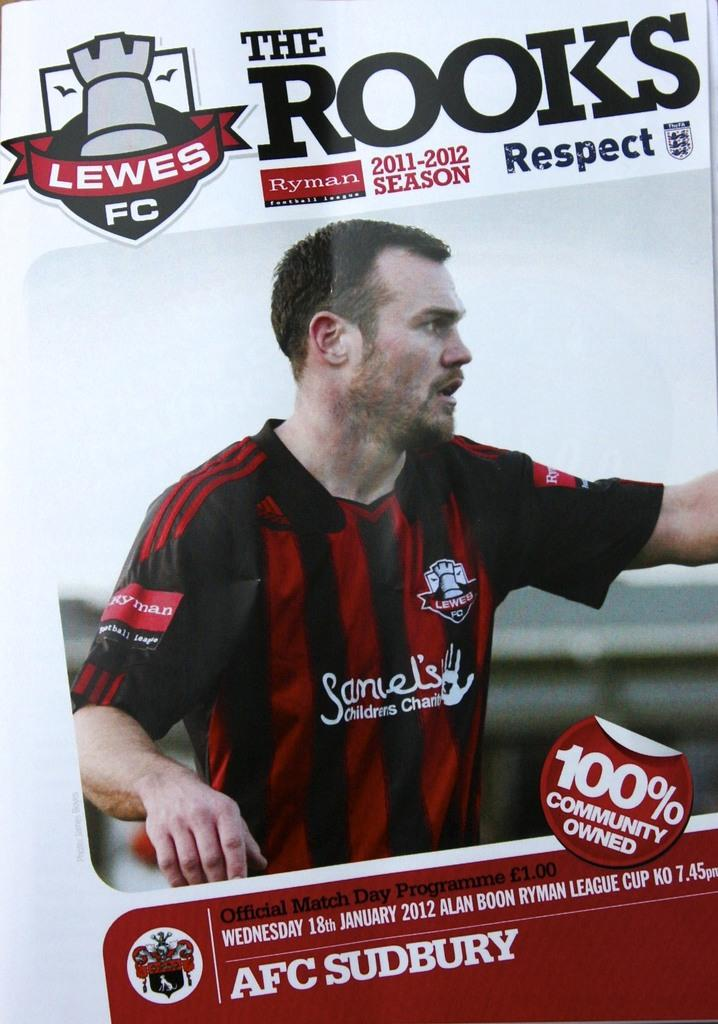<image>
Create a compact narrative representing the image presented. A soccer player on the cover of The Rooks magazine. 